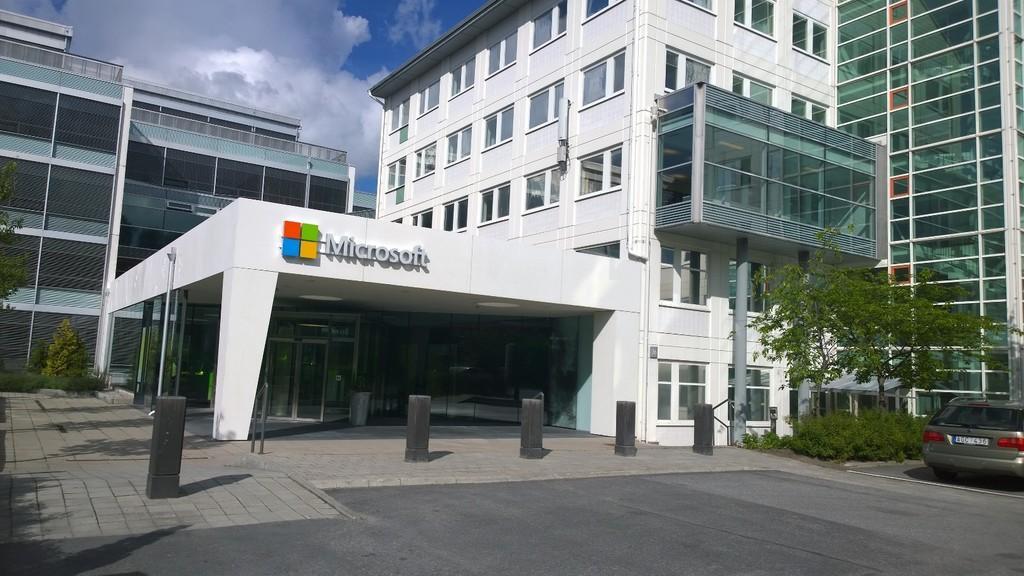In one or two sentences, can you explain what this image depicts? In this image, we can see a building. There is a car on the road. There are pillars in front of the building. There is a tree and some plants on the right side of the image. There are clouds in the sky. 